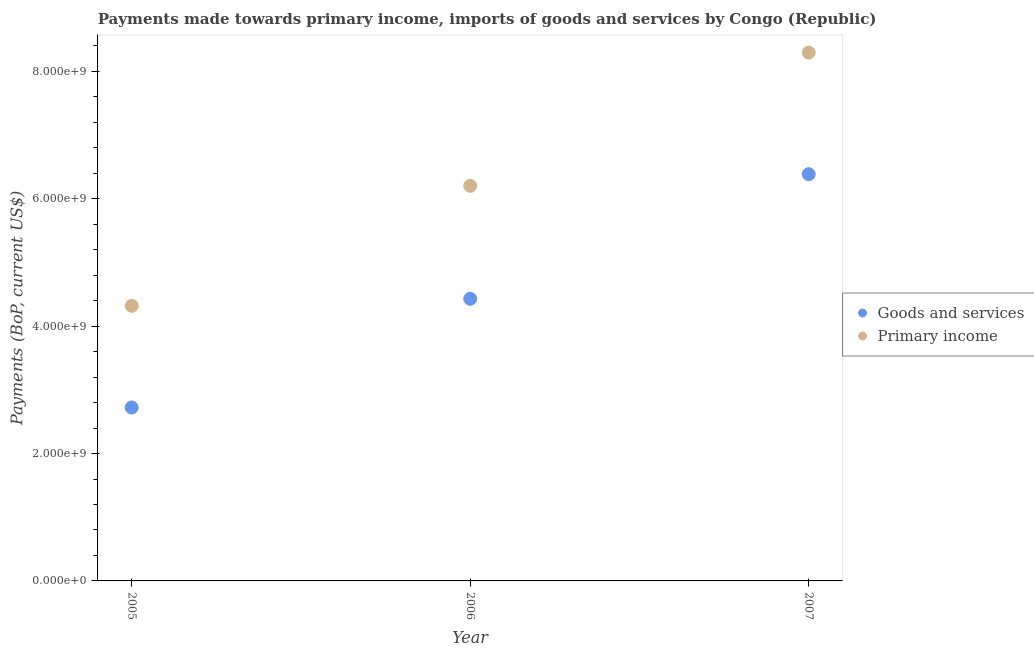Is the number of dotlines equal to the number of legend labels?
Keep it short and to the point. Yes. What is the payments made towards primary income in 2007?
Your response must be concise. 8.29e+09. Across all years, what is the maximum payments made towards goods and services?
Your response must be concise. 6.39e+09. Across all years, what is the minimum payments made towards primary income?
Give a very brief answer. 4.32e+09. In which year was the payments made towards primary income minimum?
Provide a succinct answer. 2005. What is the total payments made towards primary income in the graph?
Provide a short and direct response. 1.88e+1. What is the difference between the payments made towards goods and services in 2006 and that in 2007?
Your answer should be compact. -1.96e+09. What is the difference between the payments made towards primary income in 2007 and the payments made towards goods and services in 2005?
Give a very brief answer. 5.57e+09. What is the average payments made towards primary income per year?
Provide a short and direct response. 6.27e+09. In the year 2006, what is the difference between the payments made towards goods and services and payments made towards primary income?
Provide a succinct answer. -1.77e+09. What is the ratio of the payments made towards goods and services in 2005 to that in 2007?
Your response must be concise. 0.43. Is the difference between the payments made towards primary income in 2005 and 2007 greater than the difference between the payments made towards goods and services in 2005 and 2007?
Your answer should be very brief. No. What is the difference between the highest and the second highest payments made towards goods and services?
Offer a very short reply. 1.96e+09. What is the difference between the highest and the lowest payments made towards goods and services?
Your answer should be compact. 3.66e+09. In how many years, is the payments made towards primary income greater than the average payments made towards primary income taken over all years?
Your answer should be compact. 1. Is the sum of the payments made towards primary income in 2005 and 2007 greater than the maximum payments made towards goods and services across all years?
Your answer should be compact. Yes. Does the payments made towards primary income monotonically increase over the years?
Your answer should be compact. Yes. Is the payments made towards goods and services strictly greater than the payments made towards primary income over the years?
Ensure brevity in your answer.  No. How many years are there in the graph?
Give a very brief answer. 3. What is the difference between two consecutive major ticks on the Y-axis?
Make the answer very short. 2.00e+09. Does the graph contain any zero values?
Make the answer very short. No. Does the graph contain grids?
Keep it short and to the point. No. Where does the legend appear in the graph?
Provide a short and direct response. Center right. What is the title of the graph?
Your answer should be very brief. Payments made towards primary income, imports of goods and services by Congo (Republic). What is the label or title of the X-axis?
Offer a very short reply. Year. What is the label or title of the Y-axis?
Offer a very short reply. Payments (BoP, current US$). What is the Payments (BoP, current US$) of Goods and services in 2005?
Offer a very short reply. 2.72e+09. What is the Payments (BoP, current US$) in Primary income in 2005?
Make the answer very short. 4.32e+09. What is the Payments (BoP, current US$) in Goods and services in 2006?
Make the answer very short. 4.43e+09. What is the Payments (BoP, current US$) in Primary income in 2006?
Your response must be concise. 6.20e+09. What is the Payments (BoP, current US$) in Goods and services in 2007?
Your answer should be compact. 6.39e+09. What is the Payments (BoP, current US$) in Primary income in 2007?
Make the answer very short. 8.29e+09. Across all years, what is the maximum Payments (BoP, current US$) in Goods and services?
Provide a succinct answer. 6.39e+09. Across all years, what is the maximum Payments (BoP, current US$) of Primary income?
Your answer should be very brief. 8.29e+09. Across all years, what is the minimum Payments (BoP, current US$) of Goods and services?
Your response must be concise. 2.72e+09. Across all years, what is the minimum Payments (BoP, current US$) of Primary income?
Offer a very short reply. 4.32e+09. What is the total Payments (BoP, current US$) of Goods and services in the graph?
Offer a very short reply. 1.35e+1. What is the total Payments (BoP, current US$) of Primary income in the graph?
Ensure brevity in your answer.  1.88e+1. What is the difference between the Payments (BoP, current US$) of Goods and services in 2005 and that in 2006?
Ensure brevity in your answer.  -1.71e+09. What is the difference between the Payments (BoP, current US$) in Primary income in 2005 and that in 2006?
Keep it short and to the point. -1.88e+09. What is the difference between the Payments (BoP, current US$) in Goods and services in 2005 and that in 2007?
Provide a succinct answer. -3.66e+09. What is the difference between the Payments (BoP, current US$) in Primary income in 2005 and that in 2007?
Your answer should be very brief. -3.98e+09. What is the difference between the Payments (BoP, current US$) in Goods and services in 2006 and that in 2007?
Offer a terse response. -1.96e+09. What is the difference between the Payments (BoP, current US$) of Primary income in 2006 and that in 2007?
Ensure brevity in your answer.  -2.09e+09. What is the difference between the Payments (BoP, current US$) in Goods and services in 2005 and the Payments (BoP, current US$) in Primary income in 2006?
Your answer should be very brief. -3.48e+09. What is the difference between the Payments (BoP, current US$) of Goods and services in 2005 and the Payments (BoP, current US$) of Primary income in 2007?
Keep it short and to the point. -5.57e+09. What is the difference between the Payments (BoP, current US$) of Goods and services in 2006 and the Payments (BoP, current US$) of Primary income in 2007?
Ensure brevity in your answer.  -3.86e+09. What is the average Payments (BoP, current US$) in Goods and services per year?
Provide a short and direct response. 4.51e+09. What is the average Payments (BoP, current US$) in Primary income per year?
Your response must be concise. 6.27e+09. In the year 2005, what is the difference between the Payments (BoP, current US$) in Goods and services and Payments (BoP, current US$) in Primary income?
Make the answer very short. -1.60e+09. In the year 2006, what is the difference between the Payments (BoP, current US$) of Goods and services and Payments (BoP, current US$) of Primary income?
Offer a very short reply. -1.77e+09. In the year 2007, what is the difference between the Payments (BoP, current US$) of Goods and services and Payments (BoP, current US$) of Primary income?
Your response must be concise. -1.91e+09. What is the ratio of the Payments (BoP, current US$) of Goods and services in 2005 to that in 2006?
Provide a succinct answer. 0.61. What is the ratio of the Payments (BoP, current US$) in Primary income in 2005 to that in 2006?
Your response must be concise. 0.7. What is the ratio of the Payments (BoP, current US$) of Goods and services in 2005 to that in 2007?
Your response must be concise. 0.43. What is the ratio of the Payments (BoP, current US$) in Primary income in 2005 to that in 2007?
Offer a terse response. 0.52. What is the ratio of the Payments (BoP, current US$) of Goods and services in 2006 to that in 2007?
Keep it short and to the point. 0.69. What is the ratio of the Payments (BoP, current US$) in Primary income in 2006 to that in 2007?
Your response must be concise. 0.75. What is the difference between the highest and the second highest Payments (BoP, current US$) of Goods and services?
Ensure brevity in your answer.  1.96e+09. What is the difference between the highest and the second highest Payments (BoP, current US$) in Primary income?
Your response must be concise. 2.09e+09. What is the difference between the highest and the lowest Payments (BoP, current US$) of Goods and services?
Ensure brevity in your answer.  3.66e+09. What is the difference between the highest and the lowest Payments (BoP, current US$) of Primary income?
Offer a terse response. 3.98e+09. 